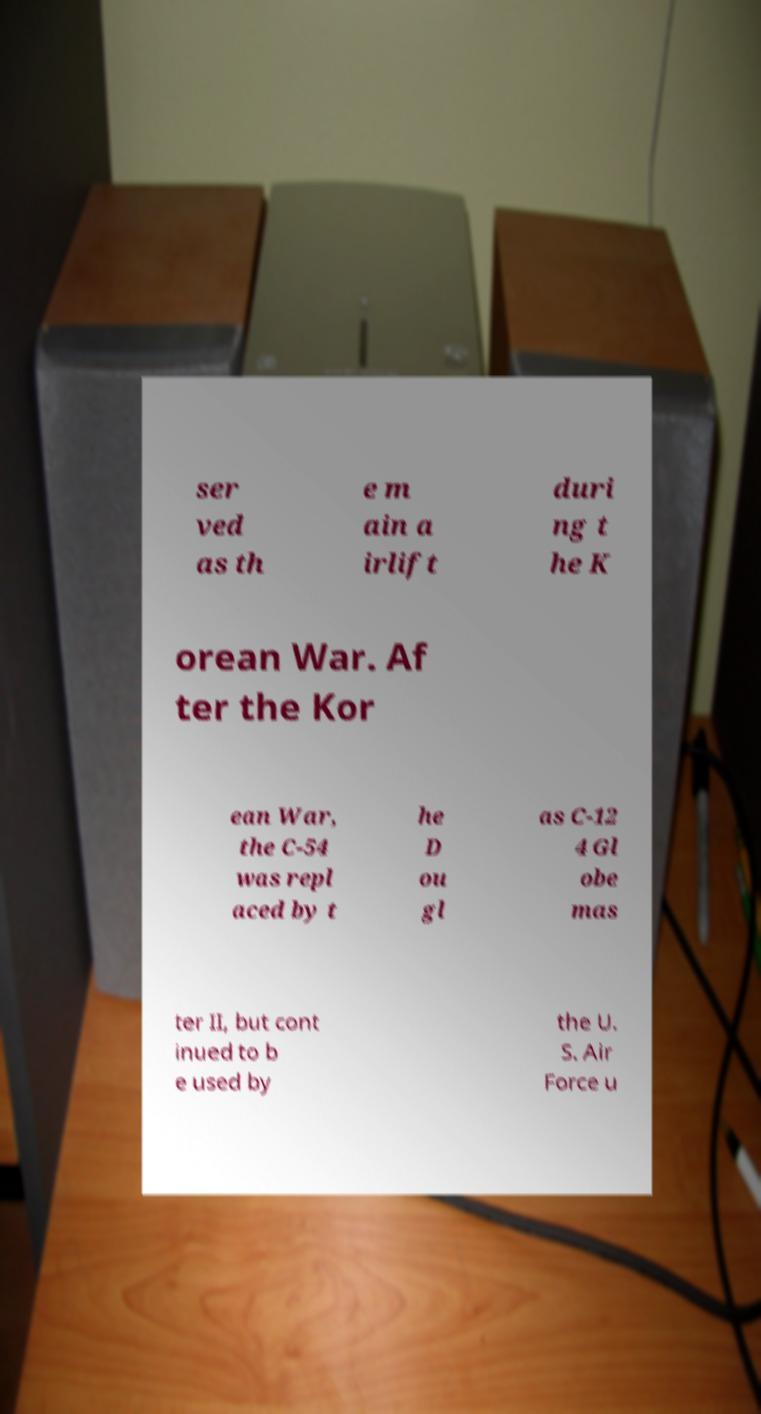What messages or text are displayed in this image? I need them in a readable, typed format. ser ved as th e m ain a irlift duri ng t he K orean War. Af ter the Kor ean War, the C-54 was repl aced by t he D ou gl as C-12 4 Gl obe mas ter II, but cont inued to b e used by the U. S. Air Force u 